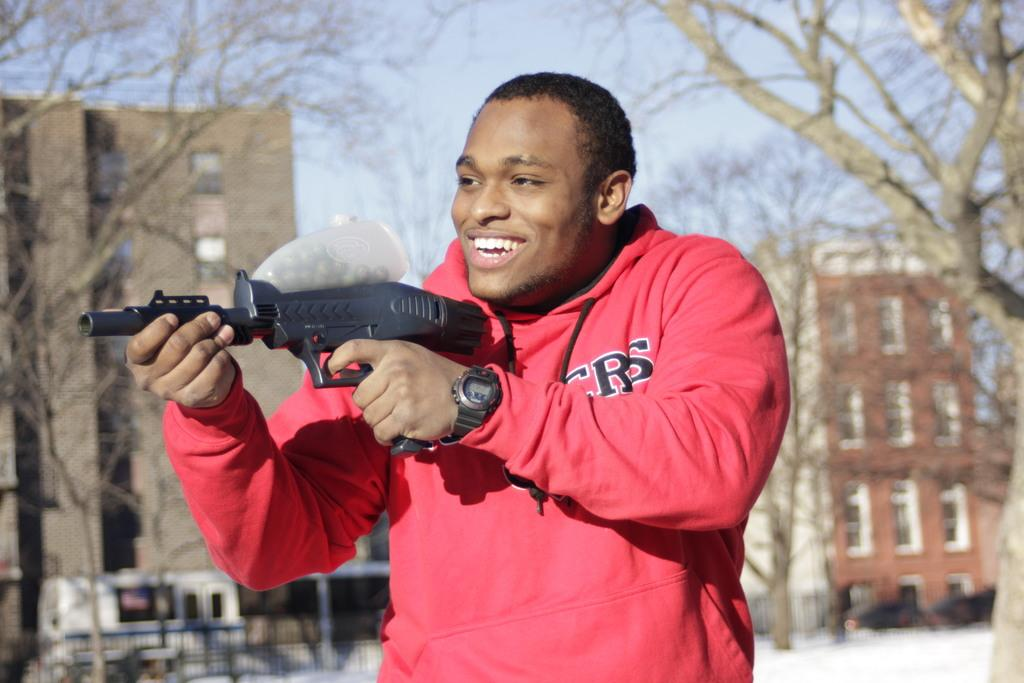Who is the main subject in the image? There is a person in the front of the image. What is the person doing in the image? The person is smiling and holding a weapon. What can be seen in the background of the image? There is railing, vehicles, trees, buildings, and the sky visible in the background of the image. What type of stitch is the person using to hold the weapon in the image? There is no indication in the image that the person is using a stitch to hold the weapon; they are simply holding it. What decision is the person making in the image? There is no indication in the image that the person is making a decision; they are just holding a weapon and smiling. 